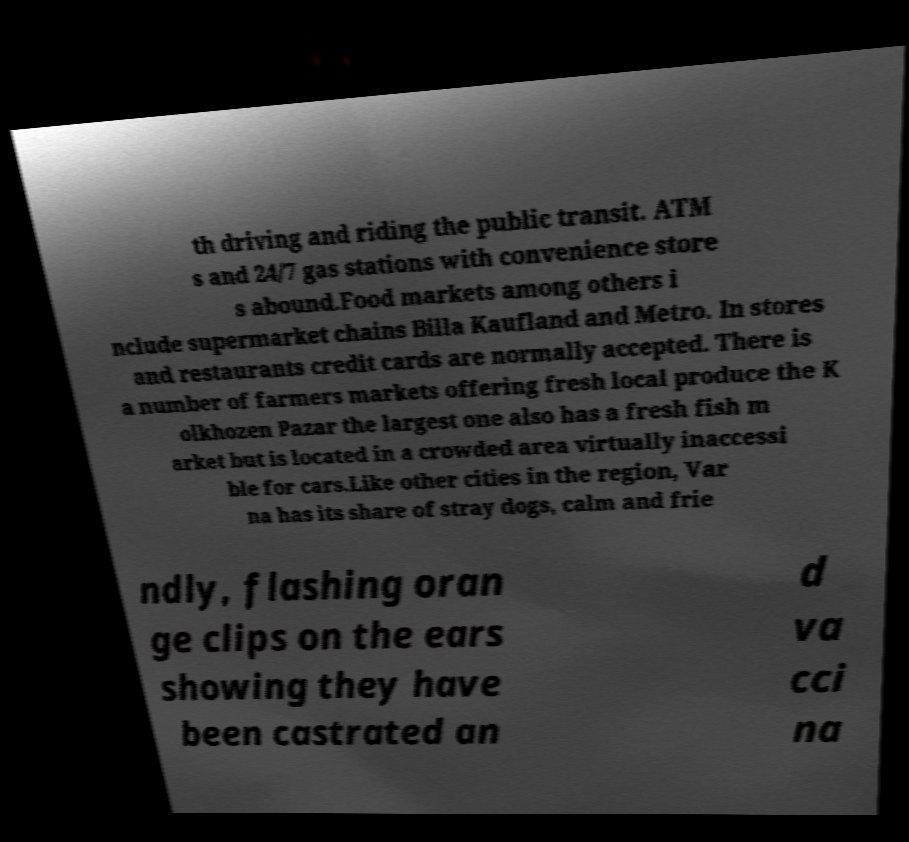I need the written content from this picture converted into text. Can you do that? th driving and riding the public transit. ATM s and 24/7 gas stations with convenience store s abound.Food markets among others i nclude supermarket chains Billa Kaufland and Metro. In stores and restaurants credit cards are normally accepted. There is a number of farmers markets offering fresh local produce the K olkhozen Pazar the largest one also has a fresh fish m arket but is located in a crowded area virtually inaccessi ble for cars.Like other cities in the region, Var na has its share of stray dogs, calm and frie ndly, flashing oran ge clips on the ears showing they have been castrated an d va cci na 